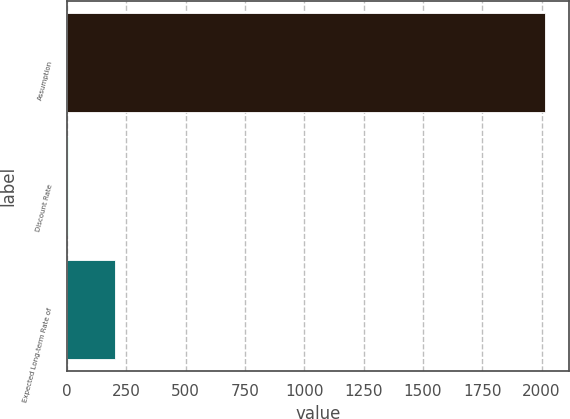Convert chart to OTSL. <chart><loc_0><loc_0><loc_500><loc_500><bar_chart><fcel>Assumption<fcel>Discount Rate<fcel>Expected Long-term Rate of<nl><fcel>2015<fcel>3.6<fcel>204.74<nl></chart> 